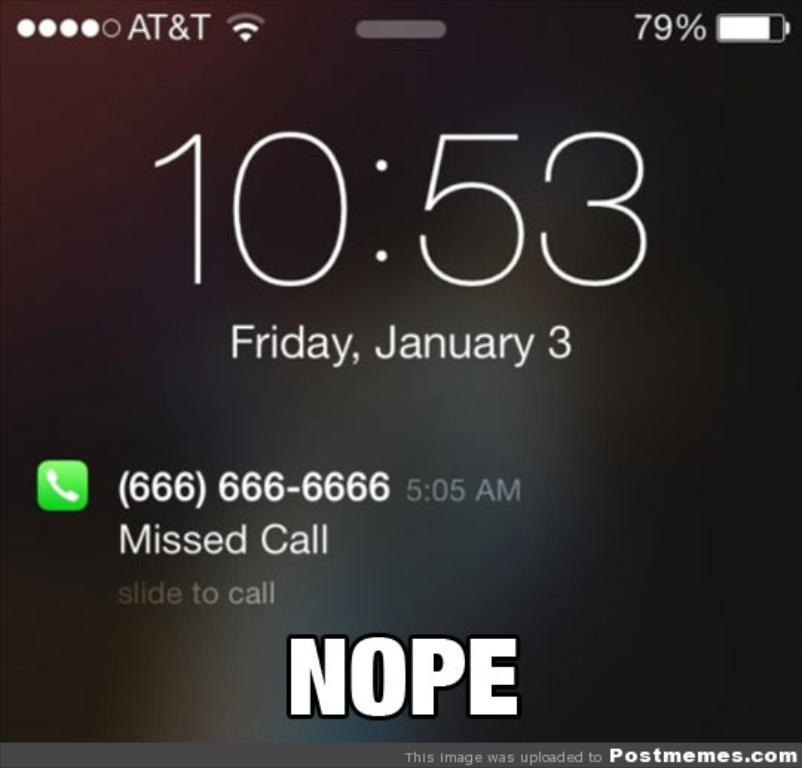<image>
Share a concise interpretation of the image provided. a screenshot of an iphone screen that says 'nope' at the bottom 